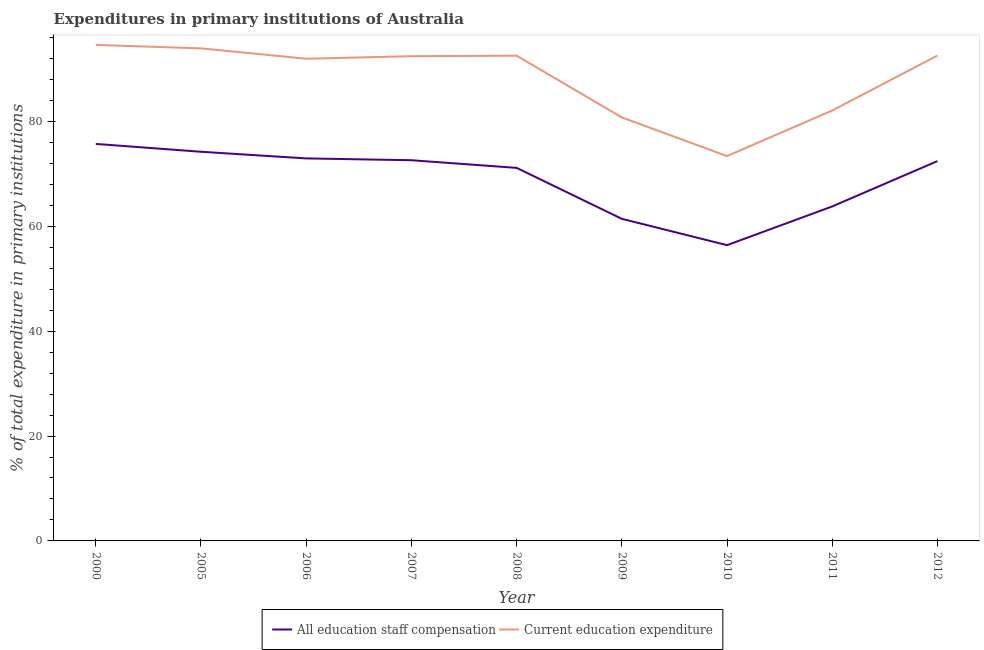Does the line corresponding to expenditure in education intersect with the line corresponding to expenditure in staff compensation?
Offer a terse response. No. Is the number of lines equal to the number of legend labels?
Offer a very short reply. Yes. What is the expenditure in education in 2000?
Give a very brief answer. 94.58. Across all years, what is the maximum expenditure in education?
Provide a succinct answer. 94.58. Across all years, what is the minimum expenditure in education?
Provide a short and direct response. 73.38. In which year was the expenditure in education maximum?
Your answer should be compact. 2000. In which year was the expenditure in staff compensation minimum?
Provide a short and direct response. 2010. What is the total expenditure in education in the graph?
Make the answer very short. 794.11. What is the difference between the expenditure in staff compensation in 2000 and that in 2009?
Make the answer very short. 14.28. What is the difference between the expenditure in staff compensation in 2012 and the expenditure in education in 2011?
Keep it short and to the point. -9.65. What is the average expenditure in education per year?
Provide a succinct answer. 88.23. In the year 2005, what is the difference between the expenditure in education and expenditure in staff compensation?
Your response must be concise. 19.71. In how many years, is the expenditure in education greater than 48 %?
Ensure brevity in your answer.  9. What is the ratio of the expenditure in staff compensation in 2000 to that in 2010?
Give a very brief answer. 1.34. Is the expenditure in staff compensation in 2007 less than that in 2008?
Provide a short and direct response. No. Is the difference between the expenditure in education in 2007 and 2010 greater than the difference between the expenditure in staff compensation in 2007 and 2010?
Ensure brevity in your answer.  Yes. What is the difference between the highest and the second highest expenditure in education?
Offer a terse response. 0.66. What is the difference between the highest and the lowest expenditure in staff compensation?
Offer a very short reply. 19.3. Is the sum of the expenditure in staff compensation in 2008 and 2012 greater than the maximum expenditure in education across all years?
Provide a succinct answer. Yes. Does the expenditure in staff compensation monotonically increase over the years?
Give a very brief answer. No. Is the expenditure in education strictly less than the expenditure in staff compensation over the years?
Offer a terse response. No. How many years are there in the graph?
Provide a short and direct response. 9. Are the values on the major ticks of Y-axis written in scientific E-notation?
Ensure brevity in your answer.  No. Does the graph contain grids?
Keep it short and to the point. No. How many legend labels are there?
Provide a succinct answer. 2. How are the legend labels stacked?
Offer a terse response. Horizontal. What is the title of the graph?
Your answer should be compact. Expenditures in primary institutions of Australia. What is the label or title of the X-axis?
Ensure brevity in your answer.  Year. What is the label or title of the Y-axis?
Offer a very short reply. % of total expenditure in primary institutions. What is the % of total expenditure in primary institutions of All education staff compensation in 2000?
Offer a very short reply. 75.7. What is the % of total expenditure in primary institutions in Current education expenditure in 2000?
Your response must be concise. 94.58. What is the % of total expenditure in primary institutions of All education staff compensation in 2005?
Your answer should be compact. 74.2. What is the % of total expenditure in primary institutions in Current education expenditure in 2005?
Give a very brief answer. 93.91. What is the % of total expenditure in primary institutions in All education staff compensation in 2006?
Keep it short and to the point. 72.93. What is the % of total expenditure in primary institutions in Current education expenditure in 2006?
Provide a succinct answer. 91.94. What is the % of total expenditure in primary institutions of All education staff compensation in 2007?
Offer a terse response. 72.59. What is the % of total expenditure in primary institutions in Current education expenditure in 2007?
Your answer should be very brief. 92.42. What is the % of total expenditure in primary institutions in All education staff compensation in 2008?
Offer a very short reply. 71.13. What is the % of total expenditure in primary institutions of Current education expenditure in 2008?
Your response must be concise. 92.52. What is the % of total expenditure in primary institutions of All education staff compensation in 2009?
Offer a very short reply. 61.42. What is the % of total expenditure in primary institutions of Current education expenditure in 2009?
Offer a terse response. 80.75. What is the % of total expenditure in primary institutions in All education staff compensation in 2010?
Make the answer very short. 56.39. What is the % of total expenditure in primary institutions of Current education expenditure in 2010?
Your response must be concise. 73.38. What is the % of total expenditure in primary institutions of All education staff compensation in 2011?
Offer a very short reply. 63.78. What is the % of total expenditure in primary institutions of Current education expenditure in 2011?
Your answer should be compact. 82.07. What is the % of total expenditure in primary institutions of All education staff compensation in 2012?
Your answer should be very brief. 72.42. What is the % of total expenditure in primary institutions of Current education expenditure in 2012?
Your answer should be very brief. 92.54. Across all years, what is the maximum % of total expenditure in primary institutions in All education staff compensation?
Provide a short and direct response. 75.7. Across all years, what is the maximum % of total expenditure in primary institutions of Current education expenditure?
Your answer should be compact. 94.58. Across all years, what is the minimum % of total expenditure in primary institutions in All education staff compensation?
Your answer should be very brief. 56.39. Across all years, what is the minimum % of total expenditure in primary institutions in Current education expenditure?
Your answer should be very brief. 73.38. What is the total % of total expenditure in primary institutions in All education staff compensation in the graph?
Offer a terse response. 620.56. What is the total % of total expenditure in primary institutions of Current education expenditure in the graph?
Your response must be concise. 794.12. What is the difference between the % of total expenditure in primary institutions in All education staff compensation in 2000 and that in 2005?
Keep it short and to the point. 1.5. What is the difference between the % of total expenditure in primary institutions of Current education expenditure in 2000 and that in 2005?
Offer a very short reply. 0.66. What is the difference between the % of total expenditure in primary institutions of All education staff compensation in 2000 and that in 2006?
Provide a short and direct response. 2.76. What is the difference between the % of total expenditure in primary institutions of Current education expenditure in 2000 and that in 2006?
Your response must be concise. 2.64. What is the difference between the % of total expenditure in primary institutions in All education staff compensation in 2000 and that in 2007?
Keep it short and to the point. 3.11. What is the difference between the % of total expenditure in primary institutions in Current education expenditure in 2000 and that in 2007?
Provide a succinct answer. 2.16. What is the difference between the % of total expenditure in primary institutions of All education staff compensation in 2000 and that in 2008?
Keep it short and to the point. 4.57. What is the difference between the % of total expenditure in primary institutions of Current education expenditure in 2000 and that in 2008?
Ensure brevity in your answer.  2.06. What is the difference between the % of total expenditure in primary institutions in All education staff compensation in 2000 and that in 2009?
Provide a short and direct response. 14.28. What is the difference between the % of total expenditure in primary institutions in Current education expenditure in 2000 and that in 2009?
Your answer should be compact. 13.82. What is the difference between the % of total expenditure in primary institutions in All education staff compensation in 2000 and that in 2010?
Offer a very short reply. 19.3. What is the difference between the % of total expenditure in primary institutions in Current education expenditure in 2000 and that in 2010?
Offer a terse response. 21.2. What is the difference between the % of total expenditure in primary institutions in All education staff compensation in 2000 and that in 2011?
Give a very brief answer. 11.92. What is the difference between the % of total expenditure in primary institutions in Current education expenditure in 2000 and that in 2011?
Ensure brevity in your answer.  12.51. What is the difference between the % of total expenditure in primary institutions in All education staff compensation in 2000 and that in 2012?
Make the answer very short. 3.28. What is the difference between the % of total expenditure in primary institutions of Current education expenditure in 2000 and that in 2012?
Offer a very short reply. 2.04. What is the difference between the % of total expenditure in primary institutions in All education staff compensation in 2005 and that in 2006?
Offer a very short reply. 1.26. What is the difference between the % of total expenditure in primary institutions of Current education expenditure in 2005 and that in 2006?
Your answer should be compact. 1.98. What is the difference between the % of total expenditure in primary institutions of All education staff compensation in 2005 and that in 2007?
Make the answer very short. 1.61. What is the difference between the % of total expenditure in primary institutions of Current education expenditure in 2005 and that in 2007?
Offer a very short reply. 1.49. What is the difference between the % of total expenditure in primary institutions in All education staff compensation in 2005 and that in 2008?
Your response must be concise. 3.07. What is the difference between the % of total expenditure in primary institutions in Current education expenditure in 2005 and that in 2008?
Provide a short and direct response. 1.39. What is the difference between the % of total expenditure in primary institutions of All education staff compensation in 2005 and that in 2009?
Your answer should be compact. 12.78. What is the difference between the % of total expenditure in primary institutions of Current education expenditure in 2005 and that in 2009?
Ensure brevity in your answer.  13.16. What is the difference between the % of total expenditure in primary institutions in All education staff compensation in 2005 and that in 2010?
Provide a succinct answer. 17.81. What is the difference between the % of total expenditure in primary institutions in Current education expenditure in 2005 and that in 2010?
Provide a succinct answer. 20.54. What is the difference between the % of total expenditure in primary institutions in All education staff compensation in 2005 and that in 2011?
Give a very brief answer. 10.42. What is the difference between the % of total expenditure in primary institutions of Current education expenditure in 2005 and that in 2011?
Provide a succinct answer. 11.85. What is the difference between the % of total expenditure in primary institutions in All education staff compensation in 2005 and that in 2012?
Provide a succinct answer. 1.78. What is the difference between the % of total expenditure in primary institutions in Current education expenditure in 2005 and that in 2012?
Offer a terse response. 1.38. What is the difference between the % of total expenditure in primary institutions of All education staff compensation in 2006 and that in 2007?
Offer a terse response. 0.35. What is the difference between the % of total expenditure in primary institutions of Current education expenditure in 2006 and that in 2007?
Make the answer very short. -0.48. What is the difference between the % of total expenditure in primary institutions of All education staff compensation in 2006 and that in 2008?
Your answer should be very brief. 1.8. What is the difference between the % of total expenditure in primary institutions in Current education expenditure in 2006 and that in 2008?
Your answer should be very brief. -0.58. What is the difference between the % of total expenditure in primary institutions in All education staff compensation in 2006 and that in 2009?
Your answer should be compact. 11.52. What is the difference between the % of total expenditure in primary institutions of Current education expenditure in 2006 and that in 2009?
Make the answer very short. 11.18. What is the difference between the % of total expenditure in primary institutions of All education staff compensation in 2006 and that in 2010?
Make the answer very short. 16.54. What is the difference between the % of total expenditure in primary institutions in Current education expenditure in 2006 and that in 2010?
Keep it short and to the point. 18.56. What is the difference between the % of total expenditure in primary institutions of All education staff compensation in 2006 and that in 2011?
Offer a terse response. 9.16. What is the difference between the % of total expenditure in primary institutions of Current education expenditure in 2006 and that in 2011?
Provide a succinct answer. 9.87. What is the difference between the % of total expenditure in primary institutions of All education staff compensation in 2006 and that in 2012?
Provide a succinct answer. 0.51. What is the difference between the % of total expenditure in primary institutions of Current education expenditure in 2006 and that in 2012?
Provide a succinct answer. -0.6. What is the difference between the % of total expenditure in primary institutions of All education staff compensation in 2007 and that in 2008?
Offer a terse response. 1.46. What is the difference between the % of total expenditure in primary institutions of Current education expenditure in 2007 and that in 2008?
Your response must be concise. -0.1. What is the difference between the % of total expenditure in primary institutions in All education staff compensation in 2007 and that in 2009?
Provide a succinct answer. 11.17. What is the difference between the % of total expenditure in primary institutions in Current education expenditure in 2007 and that in 2009?
Provide a short and direct response. 11.67. What is the difference between the % of total expenditure in primary institutions in All education staff compensation in 2007 and that in 2010?
Your answer should be very brief. 16.19. What is the difference between the % of total expenditure in primary institutions in Current education expenditure in 2007 and that in 2010?
Your answer should be very brief. 19.04. What is the difference between the % of total expenditure in primary institutions of All education staff compensation in 2007 and that in 2011?
Ensure brevity in your answer.  8.81. What is the difference between the % of total expenditure in primary institutions of Current education expenditure in 2007 and that in 2011?
Give a very brief answer. 10.35. What is the difference between the % of total expenditure in primary institutions in All education staff compensation in 2007 and that in 2012?
Provide a succinct answer. 0.17. What is the difference between the % of total expenditure in primary institutions of Current education expenditure in 2007 and that in 2012?
Offer a very short reply. -0.11. What is the difference between the % of total expenditure in primary institutions in All education staff compensation in 2008 and that in 2009?
Offer a terse response. 9.71. What is the difference between the % of total expenditure in primary institutions in Current education expenditure in 2008 and that in 2009?
Offer a terse response. 11.77. What is the difference between the % of total expenditure in primary institutions of All education staff compensation in 2008 and that in 2010?
Make the answer very short. 14.74. What is the difference between the % of total expenditure in primary institutions of Current education expenditure in 2008 and that in 2010?
Offer a terse response. 19.14. What is the difference between the % of total expenditure in primary institutions in All education staff compensation in 2008 and that in 2011?
Your answer should be compact. 7.35. What is the difference between the % of total expenditure in primary institutions in Current education expenditure in 2008 and that in 2011?
Provide a succinct answer. 10.45. What is the difference between the % of total expenditure in primary institutions of All education staff compensation in 2008 and that in 2012?
Provide a short and direct response. -1.29. What is the difference between the % of total expenditure in primary institutions of Current education expenditure in 2008 and that in 2012?
Offer a terse response. -0.02. What is the difference between the % of total expenditure in primary institutions in All education staff compensation in 2009 and that in 2010?
Provide a succinct answer. 5.02. What is the difference between the % of total expenditure in primary institutions of Current education expenditure in 2009 and that in 2010?
Your answer should be compact. 7.38. What is the difference between the % of total expenditure in primary institutions in All education staff compensation in 2009 and that in 2011?
Ensure brevity in your answer.  -2.36. What is the difference between the % of total expenditure in primary institutions of Current education expenditure in 2009 and that in 2011?
Provide a succinct answer. -1.31. What is the difference between the % of total expenditure in primary institutions in All education staff compensation in 2009 and that in 2012?
Offer a very short reply. -11. What is the difference between the % of total expenditure in primary institutions of Current education expenditure in 2009 and that in 2012?
Give a very brief answer. -11.78. What is the difference between the % of total expenditure in primary institutions in All education staff compensation in 2010 and that in 2011?
Offer a terse response. -7.38. What is the difference between the % of total expenditure in primary institutions in Current education expenditure in 2010 and that in 2011?
Your answer should be very brief. -8.69. What is the difference between the % of total expenditure in primary institutions in All education staff compensation in 2010 and that in 2012?
Keep it short and to the point. -16.03. What is the difference between the % of total expenditure in primary institutions of Current education expenditure in 2010 and that in 2012?
Keep it short and to the point. -19.16. What is the difference between the % of total expenditure in primary institutions of All education staff compensation in 2011 and that in 2012?
Ensure brevity in your answer.  -8.65. What is the difference between the % of total expenditure in primary institutions in Current education expenditure in 2011 and that in 2012?
Offer a terse response. -10.47. What is the difference between the % of total expenditure in primary institutions in All education staff compensation in 2000 and the % of total expenditure in primary institutions in Current education expenditure in 2005?
Offer a very short reply. -18.22. What is the difference between the % of total expenditure in primary institutions of All education staff compensation in 2000 and the % of total expenditure in primary institutions of Current education expenditure in 2006?
Provide a succinct answer. -16.24. What is the difference between the % of total expenditure in primary institutions in All education staff compensation in 2000 and the % of total expenditure in primary institutions in Current education expenditure in 2007?
Your response must be concise. -16.73. What is the difference between the % of total expenditure in primary institutions of All education staff compensation in 2000 and the % of total expenditure in primary institutions of Current education expenditure in 2008?
Give a very brief answer. -16.82. What is the difference between the % of total expenditure in primary institutions of All education staff compensation in 2000 and the % of total expenditure in primary institutions of Current education expenditure in 2009?
Make the answer very short. -5.06. What is the difference between the % of total expenditure in primary institutions of All education staff compensation in 2000 and the % of total expenditure in primary institutions of Current education expenditure in 2010?
Keep it short and to the point. 2.32. What is the difference between the % of total expenditure in primary institutions of All education staff compensation in 2000 and the % of total expenditure in primary institutions of Current education expenditure in 2011?
Your answer should be compact. -6.37. What is the difference between the % of total expenditure in primary institutions of All education staff compensation in 2000 and the % of total expenditure in primary institutions of Current education expenditure in 2012?
Give a very brief answer. -16.84. What is the difference between the % of total expenditure in primary institutions in All education staff compensation in 2005 and the % of total expenditure in primary institutions in Current education expenditure in 2006?
Your answer should be compact. -17.74. What is the difference between the % of total expenditure in primary institutions of All education staff compensation in 2005 and the % of total expenditure in primary institutions of Current education expenditure in 2007?
Your answer should be compact. -18.22. What is the difference between the % of total expenditure in primary institutions of All education staff compensation in 2005 and the % of total expenditure in primary institutions of Current education expenditure in 2008?
Offer a very short reply. -18.32. What is the difference between the % of total expenditure in primary institutions in All education staff compensation in 2005 and the % of total expenditure in primary institutions in Current education expenditure in 2009?
Offer a very short reply. -6.55. What is the difference between the % of total expenditure in primary institutions in All education staff compensation in 2005 and the % of total expenditure in primary institutions in Current education expenditure in 2010?
Your answer should be very brief. 0.82. What is the difference between the % of total expenditure in primary institutions in All education staff compensation in 2005 and the % of total expenditure in primary institutions in Current education expenditure in 2011?
Offer a very short reply. -7.87. What is the difference between the % of total expenditure in primary institutions of All education staff compensation in 2005 and the % of total expenditure in primary institutions of Current education expenditure in 2012?
Your answer should be very brief. -18.34. What is the difference between the % of total expenditure in primary institutions in All education staff compensation in 2006 and the % of total expenditure in primary institutions in Current education expenditure in 2007?
Offer a terse response. -19.49. What is the difference between the % of total expenditure in primary institutions of All education staff compensation in 2006 and the % of total expenditure in primary institutions of Current education expenditure in 2008?
Your answer should be compact. -19.59. What is the difference between the % of total expenditure in primary institutions in All education staff compensation in 2006 and the % of total expenditure in primary institutions in Current education expenditure in 2009?
Provide a short and direct response. -7.82. What is the difference between the % of total expenditure in primary institutions in All education staff compensation in 2006 and the % of total expenditure in primary institutions in Current education expenditure in 2010?
Provide a succinct answer. -0.44. What is the difference between the % of total expenditure in primary institutions of All education staff compensation in 2006 and the % of total expenditure in primary institutions of Current education expenditure in 2011?
Ensure brevity in your answer.  -9.13. What is the difference between the % of total expenditure in primary institutions of All education staff compensation in 2006 and the % of total expenditure in primary institutions of Current education expenditure in 2012?
Offer a terse response. -19.6. What is the difference between the % of total expenditure in primary institutions of All education staff compensation in 2007 and the % of total expenditure in primary institutions of Current education expenditure in 2008?
Provide a short and direct response. -19.93. What is the difference between the % of total expenditure in primary institutions of All education staff compensation in 2007 and the % of total expenditure in primary institutions of Current education expenditure in 2009?
Make the answer very short. -8.17. What is the difference between the % of total expenditure in primary institutions in All education staff compensation in 2007 and the % of total expenditure in primary institutions in Current education expenditure in 2010?
Offer a very short reply. -0.79. What is the difference between the % of total expenditure in primary institutions of All education staff compensation in 2007 and the % of total expenditure in primary institutions of Current education expenditure in 2011?
Your answer should be compact. -9.48. What is the difference between the % of total expenditure in primary institutions of All education staff compensation in 2007 and the % of total expenditure in primary institutions of Current education expenditure in 2012?
Keep it short and to the point. -19.95. What is the difference between the % of total expenditure in primary institutions in All education staff compensation in 2008 and the % of total expenditure in primary institutions in Current education expenditure in 2009?
Keep it short and to the point. -9.62. What is the difference between the % of total expenditure in primary institutions of All education staff compensation in 2008 and the % of total expenditure in primary institutions of Current education expenditure in 2010?
Give a very brief answer. -2.25. What is the difference between the % of total expenditure in primary institutions in All education staff compensation in 2008 and the % of total expenditure in primary institutions in Current education expenditure in 2011?
Provide a succinct answer. -10.94. What is the difference between the % of total expenditure in primary institutions in All education staff compensation in 2008 and the % of total expenditure in primary institutions in Current education expenditure in 2012?
Give a very brief answer. -21.41. What is the difference between the % of total expenditure in primary institutions of All education staff compensation in 2009 and the % of total expenditure in primary institutions of Current education expenditure in 2010?
Your answer should be compact. -11.96. What is the difference between the % of total expenditure in primary institutions in All education staff compensation in 2009 and the % of total expenditure in primary institutions in Current education expenditure in 2011?
Provide a short and direct response. -20.65. What is the difference between the % of total expenditure in primary institutions of All education staff compensation in 2009 and the % of total expenditure in primary institutions of Current education expenditure in 2012?
Offer a terse response. -31.12. What is the difference between the % of total expenditure in primary institutions of All education staff compensation in 2010 and the % of total expenditure in primary institutions of Current education expenditure in 2011?
Give a very brief answer. -25.67. What is the difference between the % of total expenditure in primary institutions of All education staff compensation in 2010 and the % of total expenditure in primary institutions of Current education expenditure in 2012?
Your response must be concise. -36.14. What is the difference between the % of total expenditure in primary institutions of All education staff compensation in 2011 and the % of total expenditure in primary institutions of Current education expenditure in 2012?
Your answer should be very brief. -28.76. What is the average % of total expenditure in primary institutions in All education staff compensation per year?
Give a very brief answer. 68.95. What is the average % of total expenditure in primary institutions in Current education expenditure per year?
Offer a terse response. 88.23. In the year 2000, what is the difference between the % of total expenditure in primary institutions of All education staff compensation and % of total expenditure in primary institutions of Current education expenditure?
Offer a terse response. -18.88. In the year 2005, what is the difference between the % of total expenditure in primary institutions in All education staff compensation and % of total expenditure in primary institutions in Current education expenditure?
Offer a very short reply. -19.71. In the year 2006, what is the difference between the % of total expenditure in primary institutions of All education staff compensation and % of total expenditure in primary institutions of Current education expenditure?
Your answer should be compact. -19. In the year 2007, what is the difference between the % of total expenditure in primary institutions of All education staff compensation and % of total expenditure in primary institutions of Current education expenditure?
Offer a very short reply. -19.83. In the year 2008, what is the difference between the % of total expenditure in primary institutions of All education staff compensation and % of total expenditure in primary institutions of Current education expenditure?
Make the answer very short. -21.39. In the year 2009, what is the difference between the % of total expenditure in primary institutions of All education staff compensation and % of total expenditure in primary institutions of Current education expenditure?
Offer a very short reply. -19.34. In the year 2010, what is the difference between the % of total expenditure in primary institutions of All education staff compensation and % of total expenditure in primary institutions of Current education expenditure?
Keep it short and to the point. -16.98. In the year 2011, what is the difference between the % of total expenditure in primary institutions of All education staff compensation and % of total expenditure in primary institutions of Current education expenditure?
Ensure brevity in your answer.  -18.29. In the year 2012, what is the difference between the % of total expenditure in primary institutions in All education staff compensation and % of total expenditure in primary institutions in Current education expenditure?
Ensure brevity in your answer.  -20.12. What is the ratio of the % of total expenditure in primary institutions of All education staff compensation in 2000 to that in 2005?
Offer a terse response. 1.02. What is the ratio of the % of total expenditure in primary institutions of Current education expenditure in 2000 to that in 2005?
Your response must be concise. 1.01. What is the ratio of the % of total expenditure in primary institutions of All education staff compensation in 2000 to that in 2006?
Provide a short and direct response. 1.04. What is the ratio of the % of total expenditure in primary institutions of Current education expenditure in 2000 to that in 2006?
Give a very brief answer. 1.03. What is the ratio of the % of total expenditure in primary institutions in All education staff compensation in 2000 to that in 2007?
Give a very brief answer. 1.04. What is the ratio of the % of total expenditure in primary institutions in Current education expenditure in 2000 to that in 2007?
Make the answer very short. 1.02. What is the ratio of the % of total expenditure in primary institutions in All education staff compensation in 2000 to that in 2008?
Provide a succinct answer. 1.06. What is the ratio of the % of total expenditure in primary institutions of Current education expenditure in 2000 to that in 2008?
Keep it short and to the point. 1.02. What is the ratio of the % of total expenditure in primary institutions of All education staff compensation in 2000 to that in 2009?
Offer a very short reply. 1.23. What is the ratio of the % of total expenditure in primary institutions of Current education expenditure in 2000 to that in 2009?
Offer a very short reply. 1.17. What is the ratio of the % of total expenditure in primary institutions of All education staff compensation in 2000 to that in 2010?
Offer a very short reply. 1.34. What is the ratio of the % of total expenditure in primary institutions in Current education expenditure in 2000 to that in 2010?
Make the answer very short. 1.29. What is the ratio of the % of total expenditure in primary institutions of All education staff compensation in 2000 to that in 2011?
Offer a terse response. 1.19. What is the ratio of the % of total expenditure in primary institutions of Current education expenditure in 2000 to that in 2011?
Provide a succinct answer. 1.15. What is the ratio of the % of total expenditure in primary institutions in All education staff compensation in 2000 to that in 2012?
Your answer should be compact. 1.05. What is the ratio of the % of total expenditure in primary institutions in Current education expenditure in 2000 to that in 2012?
Ensure brevity in your answer.  1.02. What is the ratio of the % of total expenditure in primary institutions of All education staff compensation in 2005 to that in 2006?
Your answer should be compact. 1.02. What is the ratio of the % of total expenditure in primary institutions in Current education expenditure in 2005 to that in 2006?
Ensure brevity in your answer.  1.02. What is the ratio of the % of total expenditure in primary institutions in All education staff compensation in 2005 to that in 2007?
Your response must be concise. 1.02. What is the ratio of the % of total expenditure in primary institutions in Current education expenditure in 2005 to that in 2007?
Provide a succinct answer. 1.02. What is the ratio of the % of total expenditure in primary institutions of All education staff compensation in 2005 to that in 2008?
Give a very brief answer. 1.04. What is the ratio of the % of total expenditure in primary institutions in Current education expenditure in 2005 to that in 2008?
Your answer should be very brief. 1.02. What is the ratio of the % of total expenditure in primary institutions in All education staff compensation in 2005 to that in 2009?
Make the answer very short. 1.21. What is the ratio of the % of total expenditure in primary institutions in Current education expenditure in 2005 to that in 2009?
Give a very brief answer. 1.16. What is the ratio of the % of total expenditure in primary institutions in All education staff compensation in 2005 to that in 2010?
Offer a very short reply. 1.32. What is the ratio of the % of total expenditure in primary institutions of Current education expenditure in 2005 to that in 2010?
Provide a short and direct response. 1.28. What is the ratio of the % of total expenditure in primary institutions of All education staff compensation in 2005 to that in 2011?
Your answer should be compact. 1.16. What is the ratio of the % of total expenditure in primary institutions of Current education expenditure in 2005 to that in 2011?
Provide a short and direct response. 1.14. What is the ratio of the % of total expenditure in primary institutions of All education staff compensation in 2005 to that in 2012?
Your answer should be compact. 1.02. What is the ratio of the % of total expenditure in primary institutions of Current education expenditure in 2005 to that in 2012?
Provide a short and direct response. 1.01. What is the ratio of the % of total expenditure in primary institutions in Current education expenditure in 2006 to that in 2007?
Give a very brief answer. 0.99. What is the ratio of the % of total expenditure in primary institutions in All education staff compensation in 2006 to that in 2008?
Keep it short and to the point. 1.03. What is the ratio of the % of total expenditure in primary institutions of All education staff compensation in 2006 to that in 2009?
Your answer should be very brief. 1.19. What is the ratio of the % of total expenditure in primary institutions in Current education expenditure in 2006 to that in 2009?
Your answer should be very brief. 1.14. What is the ratio of the % of total expenditure in primary institutions of All education staff compensation in 2006 to that in 2010?
Give a very brief answer. 1.29. What is the ratio of the % of total expenditure in primary institutions of Current education expenditure in 2006 to that in 2010?
Give a very brief answer. 1.25. What is the ratio of the % of total expenditure in primary institutions in All education staff compensation in 2006 to that in 2011?
Provide a succinct answer. 1.14. What is the ratio of the % of total expenditure in primary institutions of Current education expenditure in 2006 to that in 2011?
Give a very brief answer. 1.12. What is the ratio of the % of total expenditure in primary institutions in All education staff compensation in 2006 to that in 2012?
Your answer should be very brief. 1.01. What is the ratio of the % of total expenditure in primary institutions in Current education expenditure in 2006 to that in 2012?
Your answer should be compact. 0.99. What is the ratio of the % of total expenditure in primary institutions of All education staff compensation in 2007 to that in 2008?
Offer a very short reply. 1.02. What is the ratio of the % of total expenditure in primary institutions of Current education expenditure in 2007 to that in 2008?
Your answer should be compact. 1. What is the ratio of the % of total expenditure in primary institutions of All education staff compensation in 2007 to that in 2009?
Give a very brief answer. 1.18. What is the ratio of the % of total expenditure in primary institutions of Current education expenditure in 2007 to that in 2009?
Your answer should be very brief. 1.14. What is the ratio of the % of total expenditure in primary institutions of All education staff compensation in 2007 to that in 2010?
Provide a short and direct response. 1.29. What is the ratio of the % of total expenditure in primary institutions in Current education expenditure in 2007 to that in 2010?
Your answer should be compact. 1.26. What is the ratio of the % of total expenditure in primary institutions of All education staff compensation in 2007 to that in 2011?
Provide a short and direct response. 1.14. What is the ratio of the % of total expenditure in primary institutions in Current education expenditure in 2007 to that in 2011?
Provide a short and direct response. 1.13. What is the ratio of the % of total expenditure in primary institutions of All education staff compensation in 2007 to that in 2012?
Your answer should be very brief. 1. What is the ratio of the % of total expenditure in primary institutions of All education staff compensation in 2008 to that in 2009?
Make the answer very short. 1.16. What is the ratio of the % of total expenditure in primary institutions in Current education expenditure in 2008 to that in 2009?
Keep it short and to the point. 1.15. What is the ratio of the % of total expenditure in primary institutions in All education staff compensation in 2008 to that in 2010?
Your answer should be compact. 1.26. What is the ratio of the % of total expenditure in primary institutions in Current education expenditure in 2008 to that in 2010?
Your response must be concise. 1.26. What is the ratio of the % of total expenditure in primary institutions of All education staff compensation in 2008 to that in 2011?
Your response must be concise. 1.12. What is the ratio of the % of total expenditure in primary institutions in Current education expenditure in 2008 to that in 2011?
Your answer should be very brief. 1.13. What is the ratio of the % of total expenditure in primary institutions in All education staff compensation in 2008 to that in 2012?
Give a very brief answer. 0.98. What is the ratio of the % of total expenditure in primary institutions of All education staff compensation in 2009 to that in 2010?
Offer a very short reply. 1.09. What is the ratio of the % of total expenditure in primary institutions of Current education expenditure in 2009 to that in 2010?
Offer a terse response. 1.1. What is the ratio of the % of total expenditure in primary institutions of All education staff compensation in 2009 to that in 2012?
Offer a very short reply. 0.85. What is the ratio of the % of total expenditure in primary institutions of Current education expenditure in 2009 to that in 2012?
Your response must be concise. 0.87. What is the ratio of the % of total expenditure in primary institutions in All education staff compensation in 2010 to that in 2011?
Offer a terse response. 0.88. What is the ratio of the % of total expenditure in primary institutions in Current education expenditure in 2010 to that in 2011?
Make the answer very short. 0.89. What is the ratio of the % of total expenditure in primary institutions in All education staff compensation in 2010 to that in 2012?
Provide a succinct answer. 0.78. What is the ratio of the % of total expenditure in primary institutions in Current education expenditure in 2010 to that in 2012?
Provide a succinct answer. 0.79. What is the ratio of the % of total expenditure in primary institutions of All education staff compensation in 2011 to that in 2012?
Make the answer very short. 0.88. What is the ratio of the % of total expenditure in primary institutions of Current education expenditure in 2011 to that in 2012?
Your answer should be compact. 0.89. What is the difference between the highest and the second highest % of total expenditure in primary institutions of All education staff compensation?
Keep it short and to the point. 1.5. What is the difference between the highest and the second highest % of total expenditure in primary institutions in Current education expenditure?
Make the answer very short. 0.66. What is the difference between the highest and the lowest % of total expenditure in primary institutions in All education staff compensation?
Your answer should be compact. 19.3. What is the difference between the highest and the lowest % of total expenditure in primary institutions in Current education expenditure?
Your answer should be compact. 21.2. 